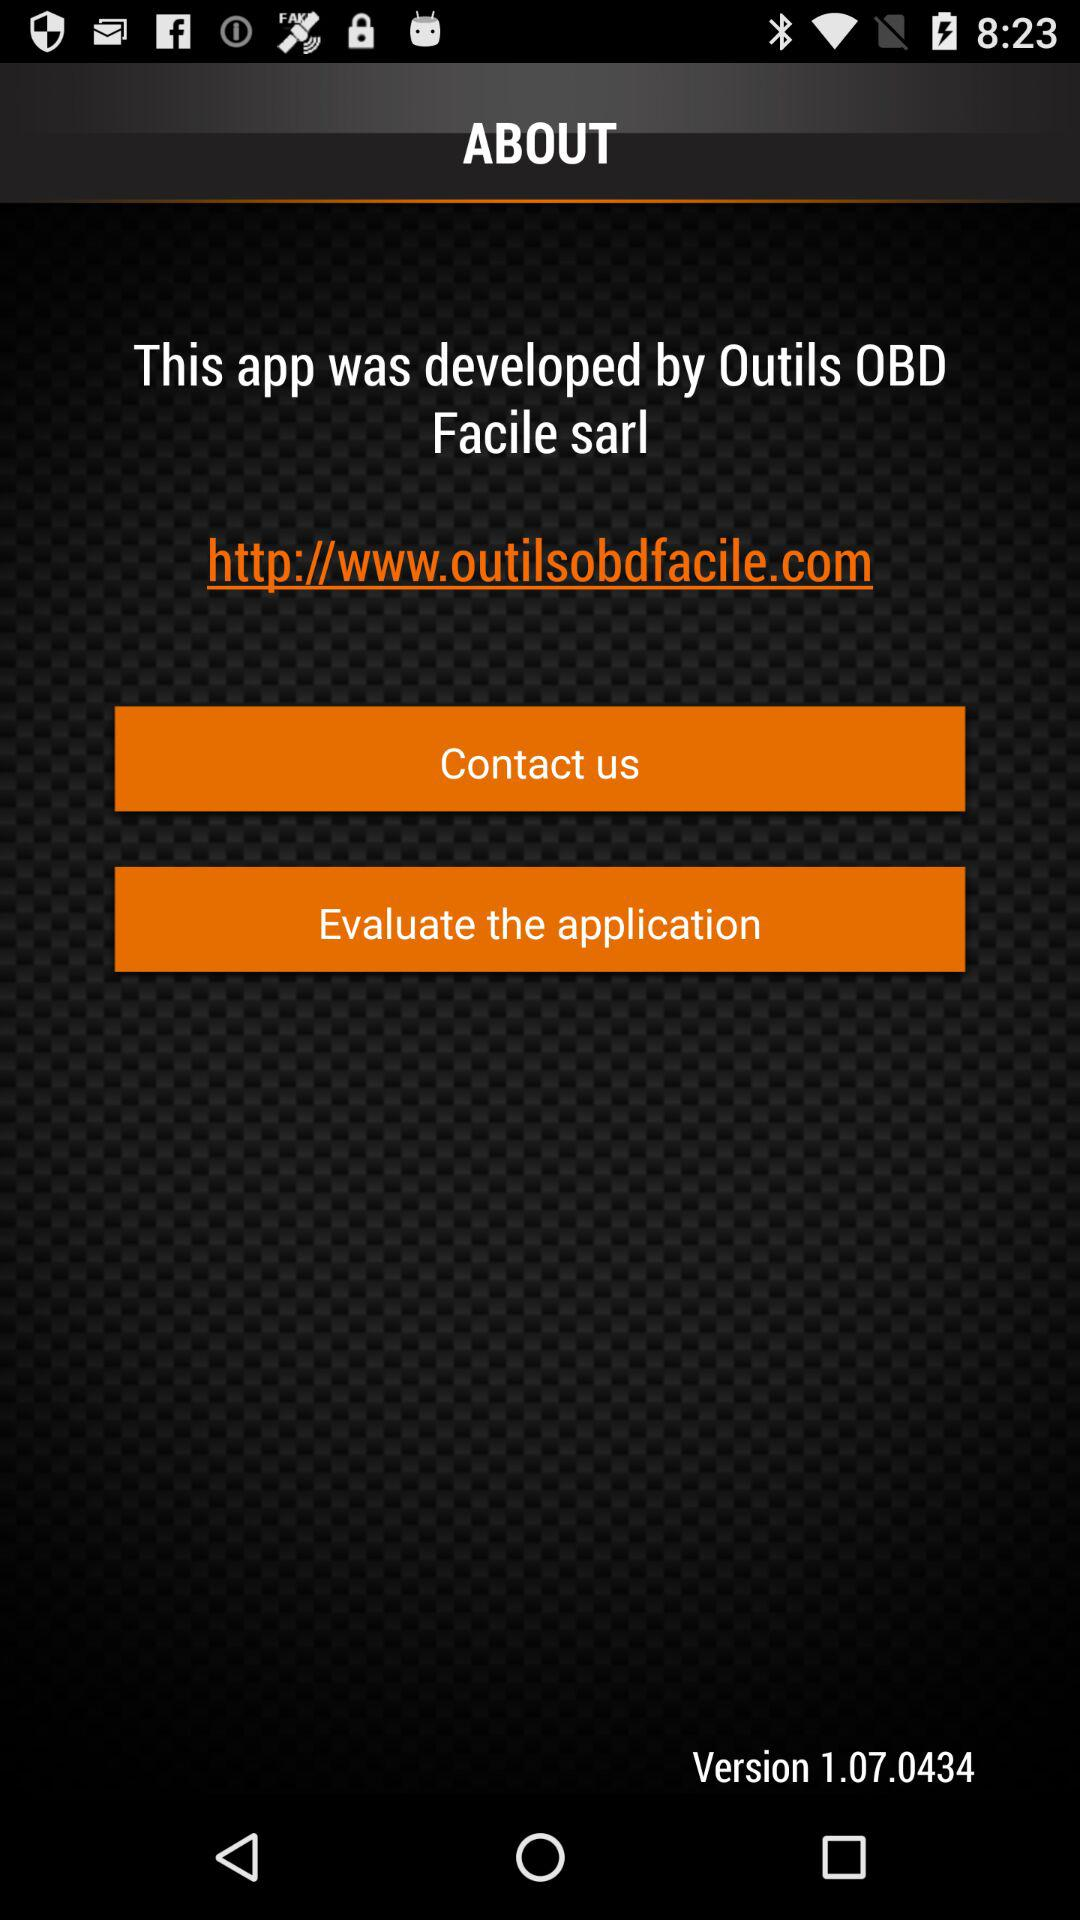What is the version of the app? The version of the application is 1.07.0434. 